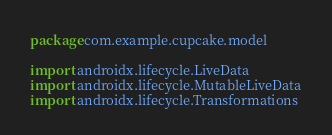Convert code to text. <code><loc_0><loc_0><loc_500><loc_500><_Kotlin_>package com.example.cupcake.model

import androidx.lifecycle.LiveData
import androidx.lifecycle.MutableLiveData
import androidx.lifecycle.Transformations</code> 